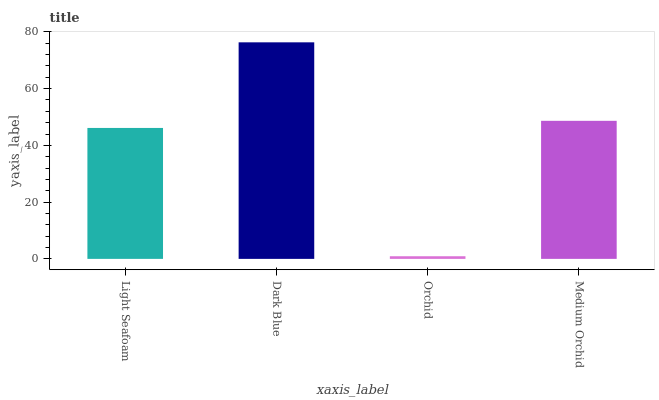Is Orchid the minimum?
Answer yes or no. Yes. Is Dark Blue the maximum?
Answer yes or no. Yes. Is Dark Blue the minimum?
Answer yes or no. No. Is Orchid the maximum?
Answer yes or no. No. Is Dark Blue greater than Orchid?
Answer yes or no. Yes. Is Orchid less than Dark Blue?
Answer yes or no. Yes. Is Orchid greater than Dark Blue?
Answer yes or no. No. Is Dark Blue less than Orchid?
Answer yes or no. No. Is Medium Orchid the high median?
Answer yes or no. Yes. Is Light Seafoam the low median?
Answer yes or no. Yes. Is Light Seafoam the high median?
Answer yes or no. No. Is Medium Orchid the low median?
Answer yes or no. No. 